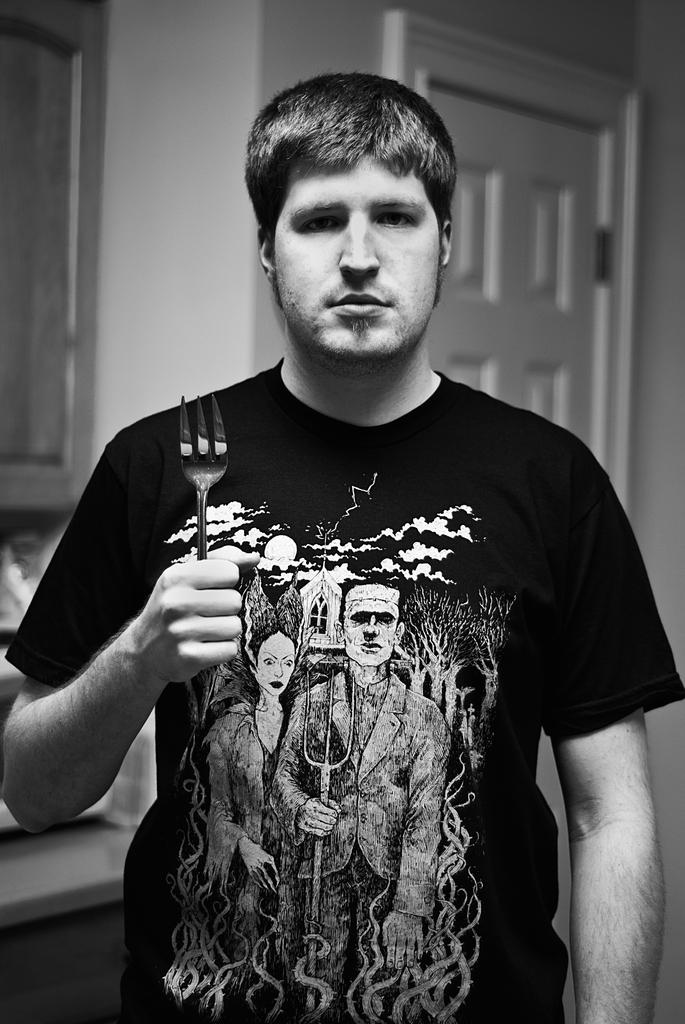Who is present in the image? There is a man in the image. What is the man wearing? The man is wearing a black t-shirt. What is the man holding in the image? The man is holding a fork. What can be seen in the background of the image? There is a window and a cupboard in the background of the image. What type of arithmetic problem is the man solving in the image? There is no arithmetic problem present in the image; the man is holding a fork and there is no indication of any mathematical activity. 